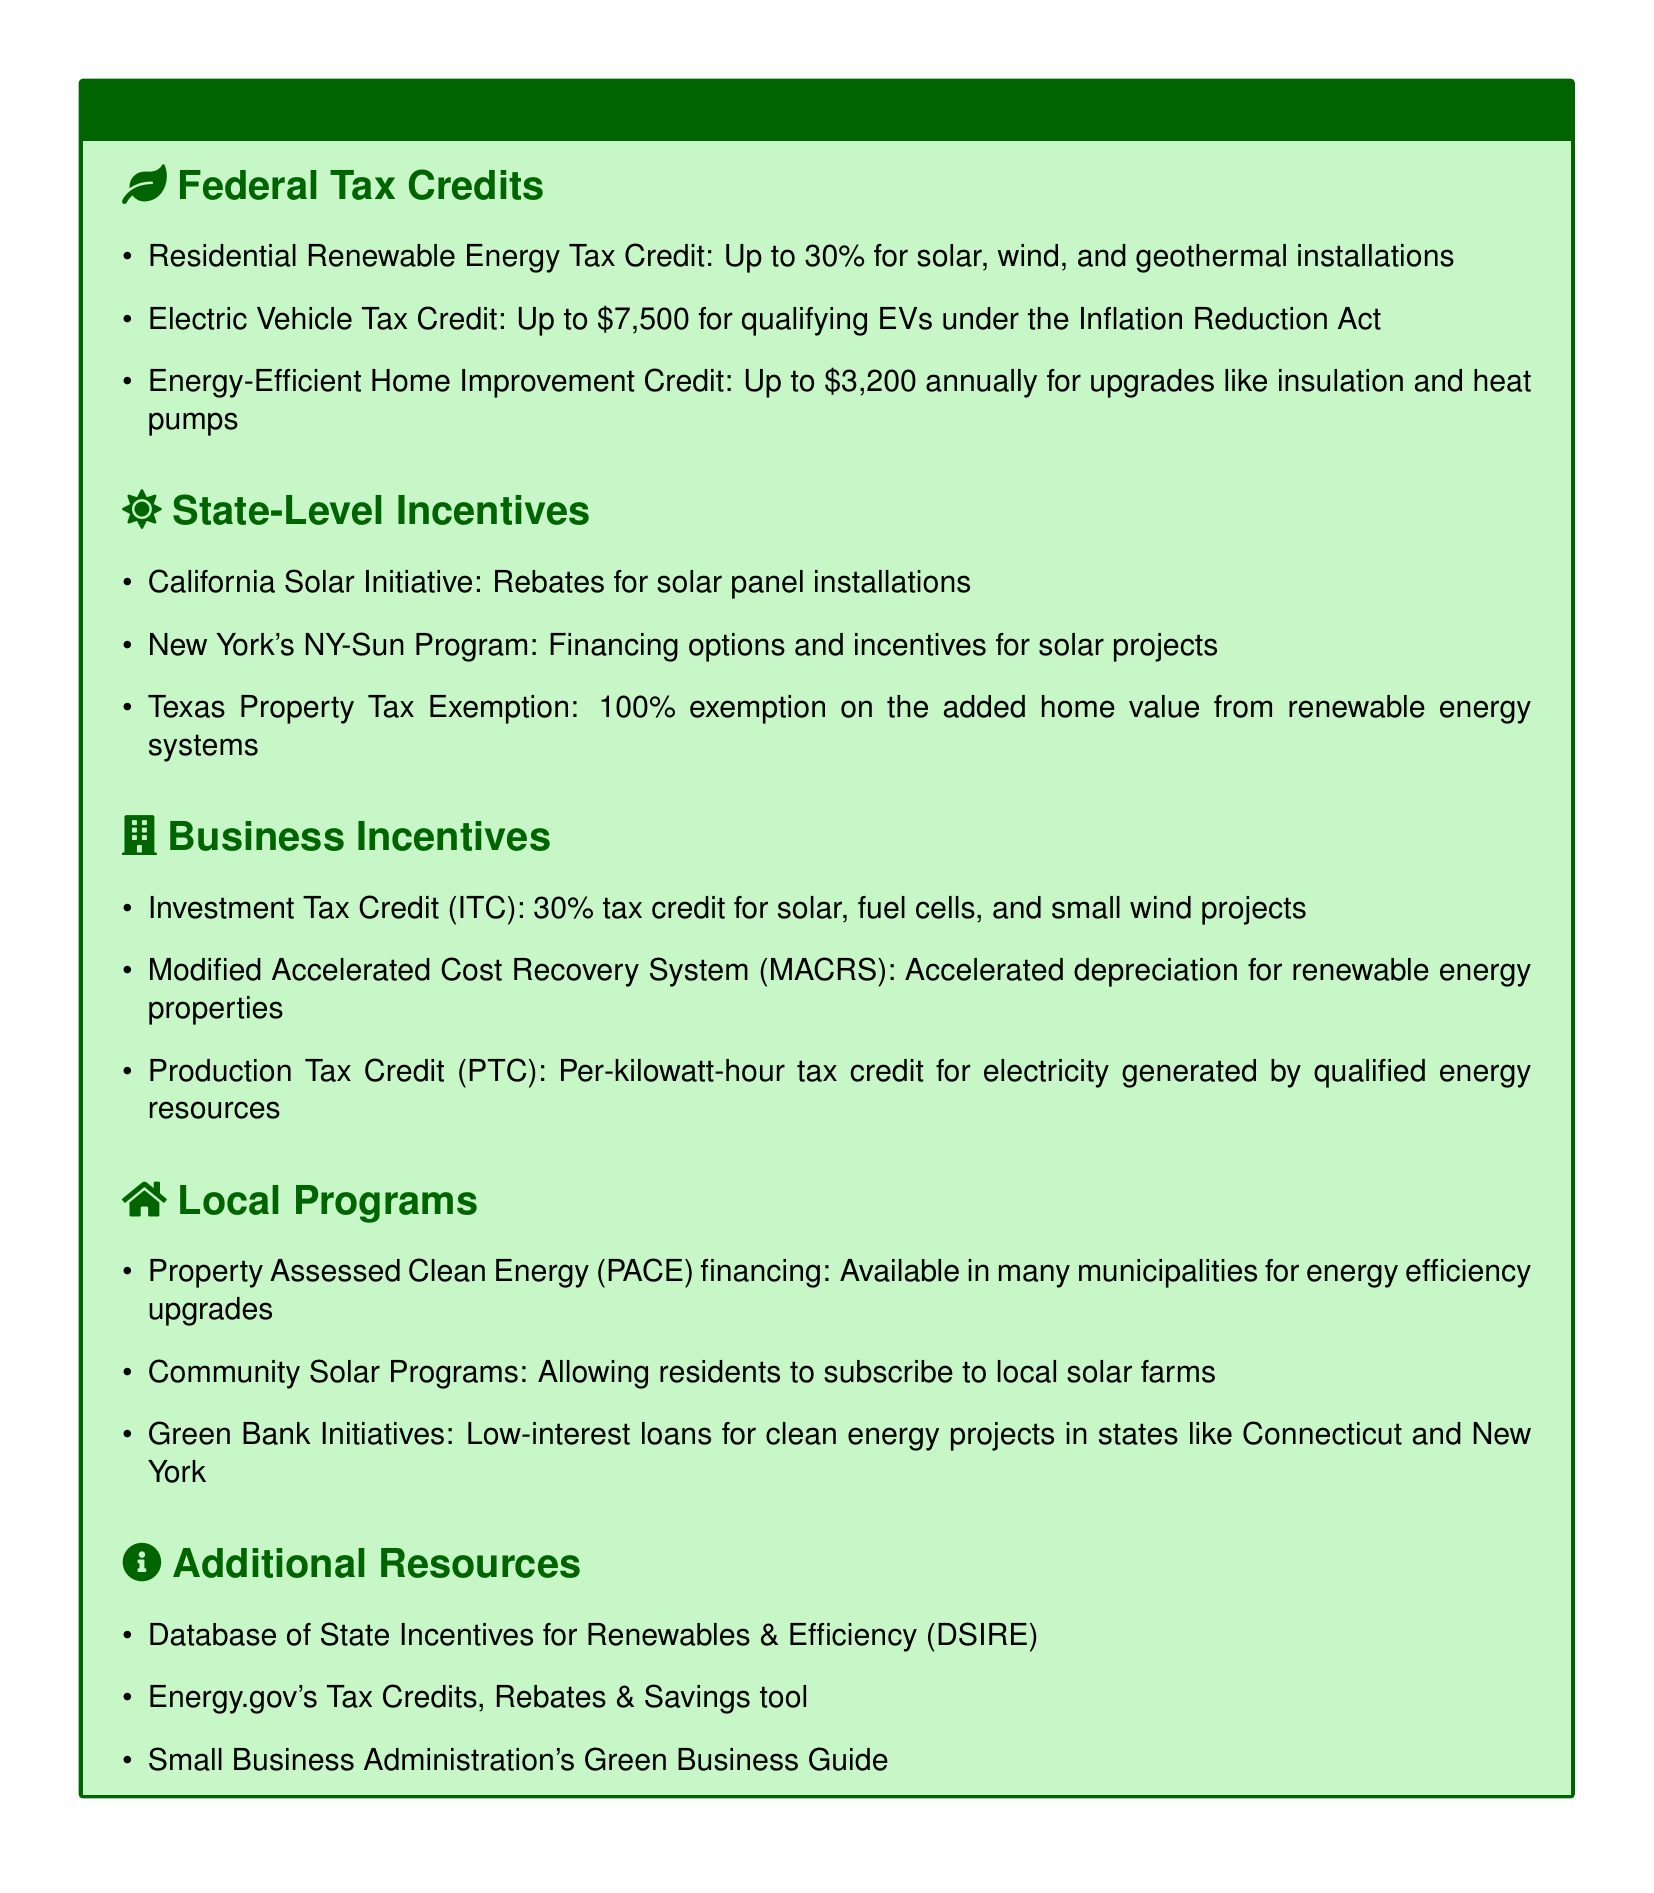what is the tax credit percentage for solar, wind, and geothermal installations? The document states that the Residential Renewable Energy Tax Credit is up to 30% for these installations.
Answer: 30% how much can individuals save annually through the Energy-Efficient Home Improvement Credit? The document lists that individuals can save up to $3,200 annually for upgrades like insulation and heat pumps.
Answer: $3,200 what is the value of the Electric Vehicle Tax Credit under the Inflation Reduction Act? The document indicates the value of the Electric Vehicle Tax Credit is up to $7,500 for qualifying EVs.
Answer: $7,500 what type of financing options does New York's NY-Sun Program provide? The document mentions that the NY-Sun Program offers financing options and incentives for solar projects.
Answer: financing options which program provides 100% property tax exemption for renewable energy systems in Texas? The document identifies the Texas Property Tax Exemption as offering 100% exemption on the added home value from renewable energy systems.
Answer: Texas Property Tax Exemption what percentage is the Investment Tax Credit for solar projects? According to the document, the Investment Tax Credit (ITC) offers a 30% tax credit for solar projects.
Answer: 30% what are Community Solar Programs designed for? The document describes Community Solar Programs as allowing residents to subscribe to local solar farms.
Answer: subscribe to local solar farms which resource provides information on state incentives for renewables? The document lists the Database of State Incentives for Renewables & Efficiency (DSIRE) as a resource for this information.
Answer: DSIRE 